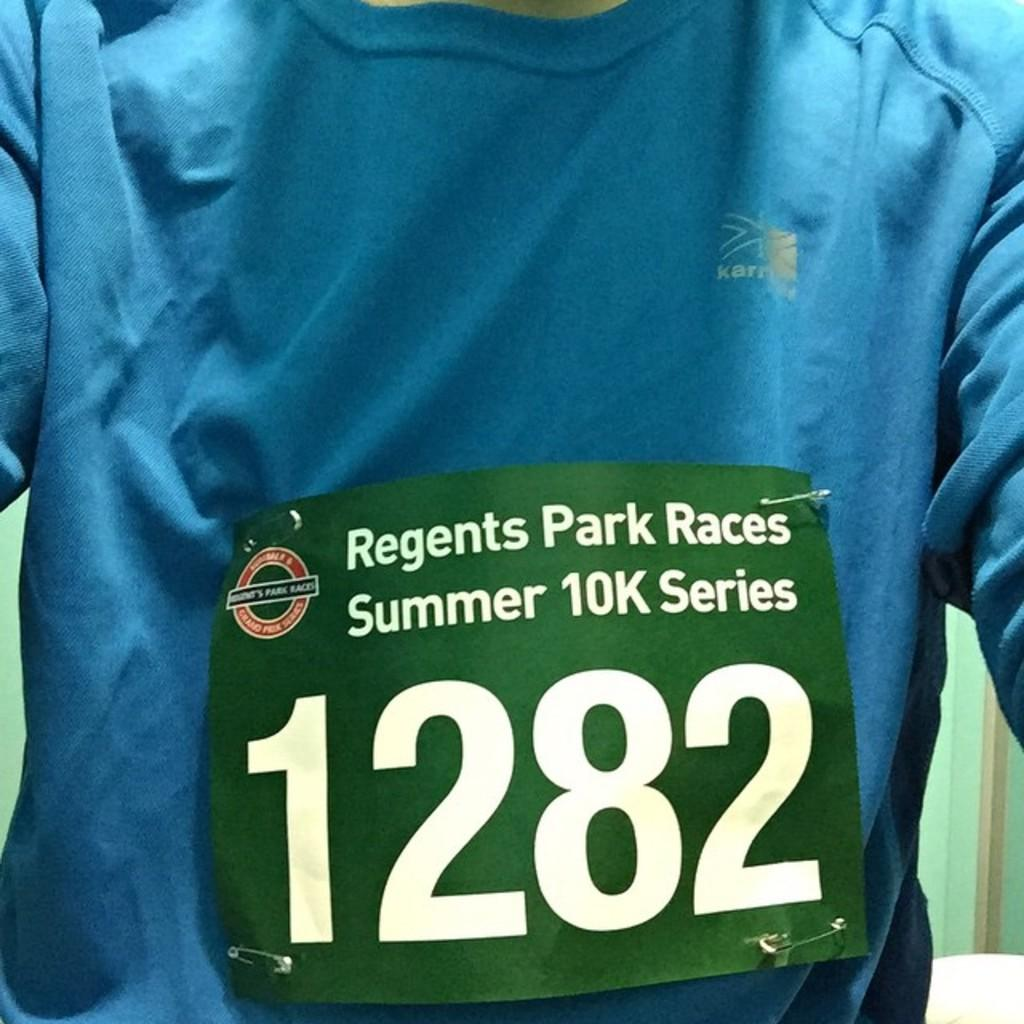<image>
Create a compact narrative representing the image presented. Person wearing a green tag which has the number 1282. 